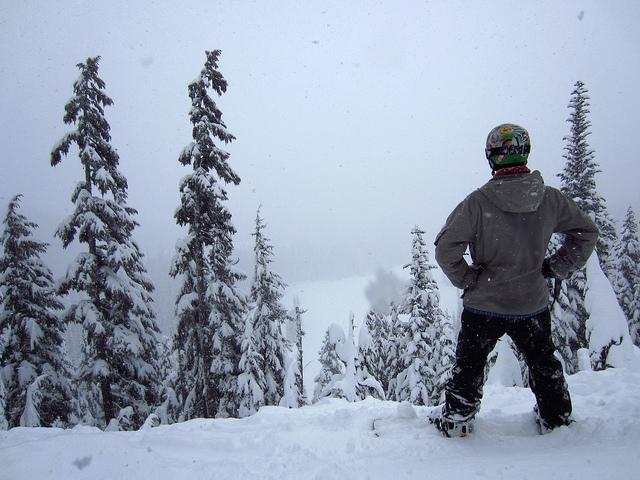What color jacket is this snowboarder wearing?
Be succinct. Gray. Is the snowboarder facing towards or away from the camera?
Concise answer only. Away. Are the trees covered in snow?
Answer briefly. Yes. 